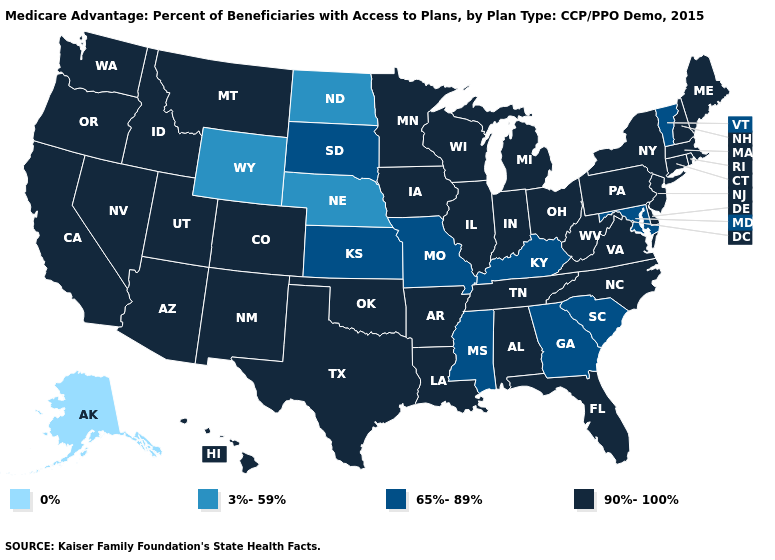Among the states that border Arkansas , which have the highest value?
Be succinct. Louisiana, Oklahoma, Tennessee, Texas. Does Montana have a lower value than Nevada?
Write a very short answer. No. Which states hav the highest value in the Northeast?
Give a very brief answer. Connecticut, Massachusetts, Maine, New Hampshire, New Jersey, New York, Pennsylvania, Rhode Island. What is the highest value in states that border New Jersey?
Concise answer only. 90%-100%. What is the lowest value in states that border Maine?
Short answer required. 90%-100%. What is the highest value in the Northeast ?
Write a very short answer. 90%-100%. What is the value of Massachusetts?
Keep it brief. 90%-100%. Name the states that have a value in the range 65%-89%?
Give a very brief answer. Georgia, Kansas, Kentucky, Maryland, Missouri, Mississippi, South Carolina, South Dakota, Vermont. Does Nebraska have the lowest value in the USA?
Keep it brief. No. Does New York have the same value as Pennsylvania?
Be succinct. Yes. What is the highest value in the USA?
Quick response, please. 90%-100%. Among the states that border Washington , which have the lowest value?
Give a very brief answer. Idaho, Oregon. Name the states that have a value in the range 0%?
Answer briefly. Alaska. Does the map have missing data?
Be succinct. No. Among the states that border Delaware , does Pennsylvania have the lowest value?
Answer briefly. No. 